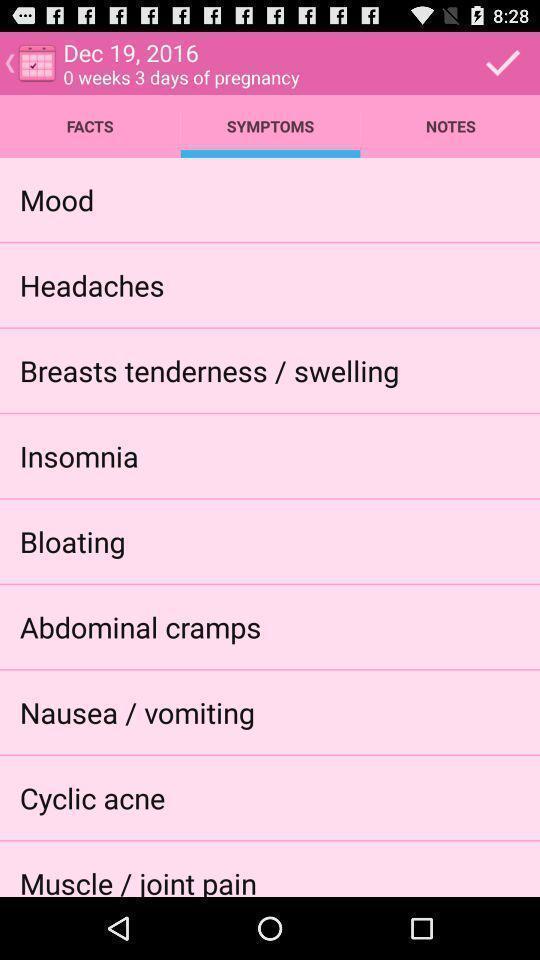Explain what's happening in this screen capture. Page showing the options in symptoms tab. 